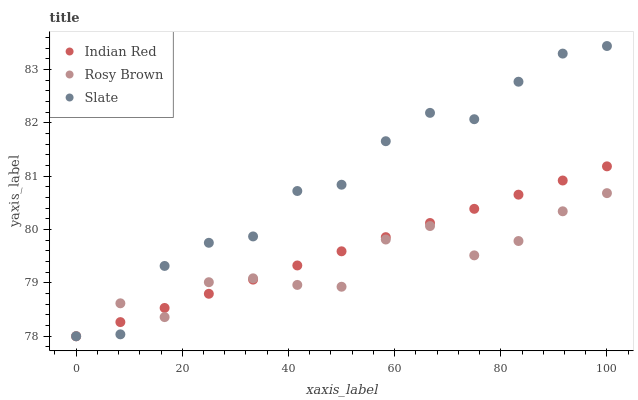Does Rosy Brown have the minimum area under the curve?
Answer yes or no. Yes. Does Slate have the maximum area under the curve?
Answer yes or no. Yes. Does Indian Red have the minimum area under the curve?
Answer yes or no. No. Does Indian Red have the maximum area under the curve?
Answer yes or no. No. Is Indian Red the smoothest?
Answer yes or no. Yes. Is Slate the roughest?
Answer yes or no. Yes. Is Rosy Brown the smoothest?
Answer yes or no. No. Is Rosy Brown the roughest?
Answer yes or no. No. Does Slate have the lowest value?
Answer yes or no. Yes. Does Slate have the highest value?
Answer yes or no. Yes. Does Indian Red have the highest value?
Answer yes or no. No. Does Indian Red intersect Slate?
Answer yes or no. Yes. Is Indian Red less than Slate?
Answer yes or no. No. Is Indian Red greater than Slate?
Answer yes or no. No. 